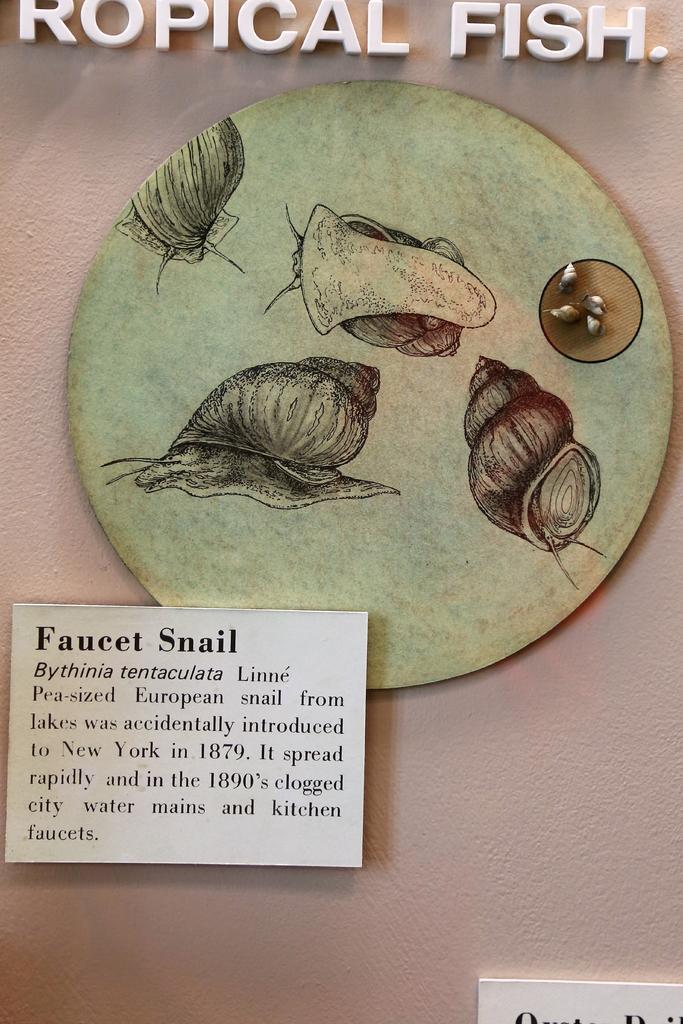Can you describe this image briefly? Here we can see drawings on a round board on a platform and we can also see two tags and on one tag we can see texts written on it and at the top we can see a text written on the platform. 